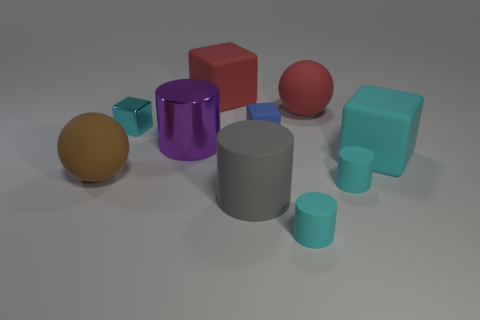Is there any other thing that has the same material as the blue block?
Give a very brief answer. Yes. Does the big gray matte object have the same shape as the big purple shiny thing?
Offer a terse response. Yes. What number of large objects are gray rubber cylinders or purple metallic objects?
Offer a terse response. 2. Is the number of cyan cylinders greater than the number of large brown matte objects?
Give a very brief answer. Yes. There is a red block that is made of the same material as the small blue block; what size is it?
Your response must be concise. Large. Do the sphere that is to the right of the large brown matte sphere and the cyan cylinder on the left side of the large red sphere have the same size?
Your response must be concise. No. What number of objects are either large rubber balls that are in front of the large cyan block or big gray cylinders?
Your answer should be compact. 2. Is the number of brown rubber things less than the number of tiny purple objects?
Provide a succinct answer. No. The red object left of the cyan cylinder that is in front of the tiny matte cylinder that is on the right side of the large red rubber sphere is what shape?
Your answer should be compact. Cube. There is a big object that is the same color as the small metal object; what shape is it?
Keep it short and to the point. Cube. 